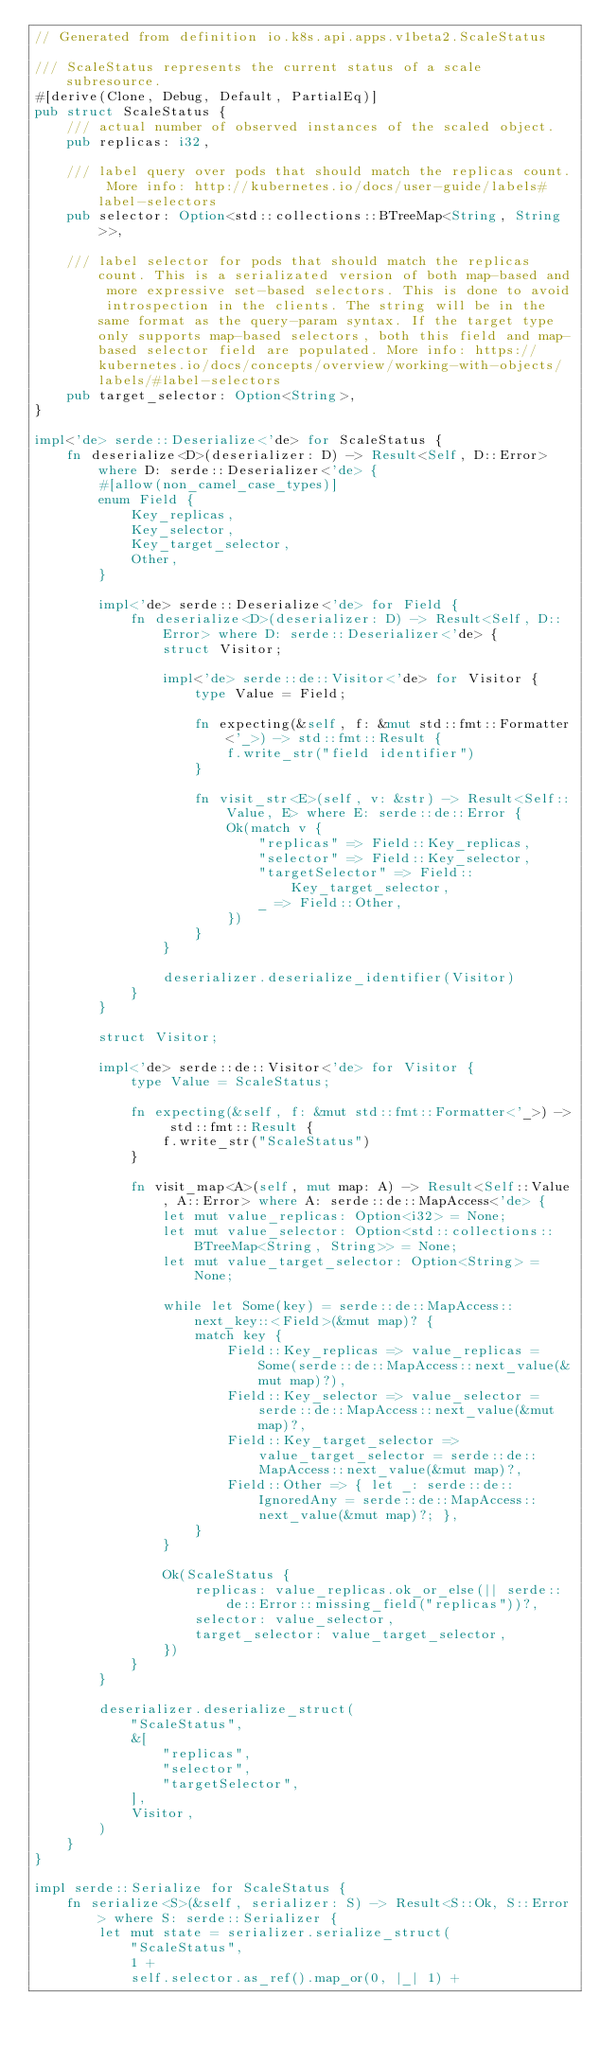<code> <loc_0><loc_0><loc_500><loc_500><_Rust_>// Generated from definition io.k8s.api.apps.v1beta2.ScaleStatus

/// ScaleStatus represents the current status of a scale subresource.
#[derive(Clone, Debug, Default, PartialEq)]
pub struct ScaleStatus {
    /// actual number of observed instances of the scaled object.
    pub replicas: i32,

    /// label query over pods that should match the replicas count. More info: http://kubernetes.io/docs/user-guide/labels#label-selectors
    pub selector: Option<std::collections::BTreeMap<String, String>>,

    /// label selector for pods that should match the replicas count. This is a serializated version of both map-based and more expressive set-based selectors. This is done to avoid introspection in the clients. The string will be in the same format as the query-param syntax. If the target type only supports map-based selectors, both this field and map-based selector field are populated. More info: https://kubernetes.io/docs/concepts/overview/working-with-objects/labels/#label-selectors
    pub target_selector: Option<String>,
}

impl<'de> serde::Deserialize<'de> for ScaleStatus {
    fn deserialize<D>(deserializer: D) -> Result<Self, D::Error> where D: serde::Deserializer<'de> {
        #[allow(non_camel_case_types)]
        enum Field {
            Key_replicas,
            Key_selector,
            Key_target_selector,
            Other,
        }

        impl<'de> serde::Deserialize<'de> for Field {
            fn deserialize<D>(deserializer: D) -> Result<Self, D::Error> where D: serde::Deserializer<'de> {
                struct Visitor;

                impl<'de> serde::de::Visitor<'de> for Visitor {
                    type Value = Field;

                    fn expecting(&self, f: &mut std::fmt::Formatter<'_>) -> std::fmt::Result {
                        f.write_str("field identifier")
                    }

                    fn visit_str<E>(self, v: &str) -> Result<Self::Value, E> where E: serde::de::Error {
                        Ok(match v {
                            "replicas" => Field::Key_replicas,
                            "selector" => Field::Key_selector,
                            "targetSelector" => Field::Key_target_selector,
                            _ => Field::Other,
                        })
                    }
                }

                deserializer.deserialize_identifier(Visitor)
            }
        }

        struct Visitor;

        impl<'de> serde::de::Visitor<'de> for Visitor {
            type Value = ScaleStatus;

            fn expecting(&self, f: &mut std::fmt::Formatter<'_>) -> std::fmt::Result {
                f.write_str("ScaleStatus")
            }

            fn visit_map<A>(self, mut map: A) -> Result<Self::Value, A::Error> where A: serde::de::MapAccess<'de> {
                let mut value_replicas: Option<i32> = None;
                let mut value_selector: Option<std::collections::BTreeMap<String, String>> = None;
                let mut value_target_selector: Option<String> = None;

                while let Some(key) = serde::de::MapAccess::next_key::<Field>(&mut map)? {
                    match key {
                        Field::Key_replicas => value_replicas = Some(serde::de::MapAccess::next_value(&mut map)?),
                        Field::Key_selector => value_selector = serde::de::MapAccess::next_value(&mut map)?,
                        Field::Key_target_selector => value_target_selector = serde::de::MapAccess::next_value(&mut map)?,
                        Field::Other => { let _: serde::de::IgnoredAny = serde::de::MapAccess::next_value(&mut map)?; },
                    }
                }

                Ok(ScaleStatus {
                    replicas: value_replicas.ok_or_else(|| serde::de::Error::missing_field("replicas"))?,
                    selector: value_selector,
                    target_selector: value_target_selector,
                })
            }
        }

        deserializer.deserialize_struct(
            "ScaleStatus",
            &[
                "replicas",
                "selector",
                "targetSelector",
            ],
            Visitor,
        )
    }
}

impl serde::Serialize for ScaleStatus {
    fn serialize<S>(&self, serializer: S) -> Result<S::Ok, S::Error> where S: serde::Serializer {
        let mut state = serializer.serialize_struct(
            "ScaleStatus",
            1 +
            self.selector.as_ref().map_or(0, |_| 1) +</code> 